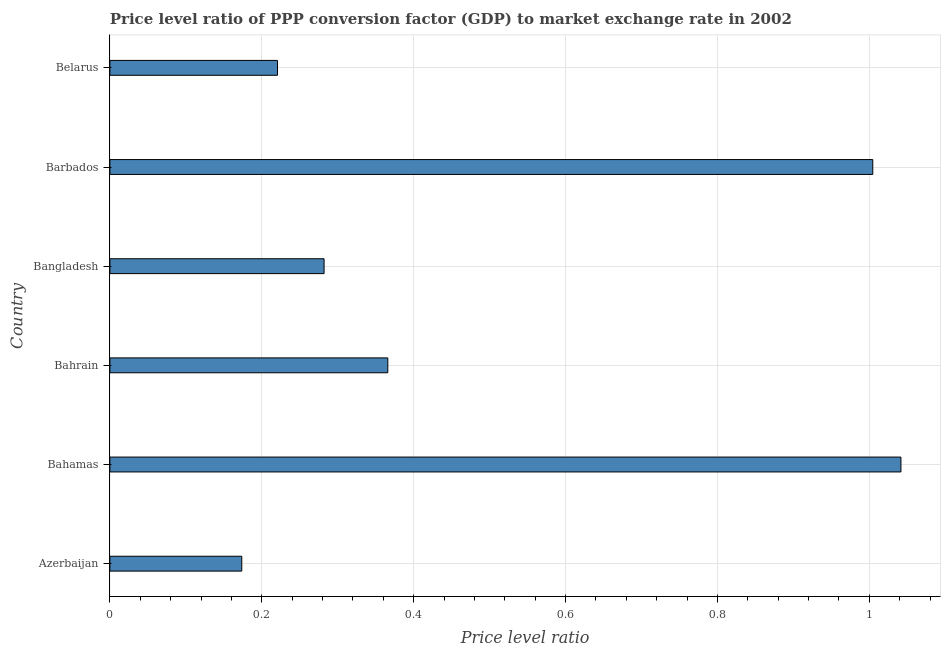What is the title of the graph?
Provide a succinct answer. Price level ratio of PPP conversion factor (GDP) to market exchange rate in 2002. What is the label or title of the X-axis?
Provide a short and direct response. Price level ratio. What is the label or title of the Y-axis?
Your answer should be compact. Country. What is the price level ratio in Bahrain?
Your answer should be compact. 0.37. Across all countries, what is the maximum price level ratio?
Your response must be concise. 1.04. Across all countries, what is the minimum price level ratio?
Ensure brevity in your answer.  0.17. In which country was the price level ratio maximum?
Ensure brevity in your answer.  Bahamas. In which country was the price level ratio minimum?
Your answer should be compact. Azerbaijan. What is the sum of the price level ratio?
Provide a short and direct response. 3.09. What is the difference between the price level ratio in Azerbaijan and Belarus?
Make the answer very short. -0.05. What is the average price level ratio per country?
Give a very brief answer. 0.52. What is the median price level ratio?
Your answer should be compact. 0.32. What is the ratio of the price level ratio in Barbados to that in Belarus?
Your answer should be compact. 4.55. Is the price level ratio in Bahamas less than that in Bahrain?
Your answer should be very brief. No. Is the difference between the price level ratio in Azerbaijan and Belarus greater than the difference between any two countries?
Offer a very short reply. No. What is the difference between the highest and the second highest price level ratio?
Your response must be concise. 0.04. Is the sum of the price level ratio in Bahamas and Bahrain greater than the maximum price level ratio across all countries?
Provide a short and direct response. Yes. What is the difference between the highest and the lowest price level ratio?
Your answer should be very brief. 0.87. In how many countries, is the price level ratio greater than the average price level ratio taken over all countries?
Provide a short and direct response. 2. How many bars are there?
Your answer should be very brief. 6. Are all the bars in the graph horizontal?
Your answer should be very brief. Yes. How many countries are there in the graph?
Ensure brevity in your answer.  6. What is the difference between two consecutive major ticks on the X-axis?
Give a very brief answer. 0.2. What is the Price level ratio of Azerbaijan?
Offer a terse response. 0.17. What is the Price level ratio in Bahamas?
Keep it short and to the point. 1.04. What is the Price level ratio of Bahrain?
Ensure brevity in your answer.  0.37. What is the Price level ratio of Bangladesh?
Offer a terse response. 0.28. What is the Price level ratio in Barbados?
Ensure brevity in your answer.  1. What is the Price level ratio in Belarus?
Give a very brief answer. 0.22. What is the difference between the Price level ratio in Azerbaijan and Bahamas?
Your answer should be compact. -0.87. What is the difference between the Price level ratio in Azerbaijan and Bahrain?
Your response must be concise. -0.19. What is the difference between the Price level ratio in Azerbaijan and Bangladesh?
Provide a short and direct response. -0.11. What is the difference between the Price level ratio in Azerbaijan and Barbados?
Ensure brevity in your answer.  -0.83. What is the difference between the Price level ratio in Azerbaijan and Belarus?
Offer a very short reply. -0.05. What is the difference between the Price level ratio in Bahamas and Bahrain?
Make the answer very short. 0.68. What is the difference between the Price level ratio in Bahamas and Bangladesh?
Ensure brevity in your answer.  0.76. What is the difference between the Price level ratio in Bahamas and Barbados?
Ensure brevity in your answer.  0.04. What is the difference between the Price level ratio in Bahamas and Belarus?
Your response must be concise. 0.82. What is the difference between the Price level ratio in Bahrain and Bangladesh?
Ensure brevity in your answer.  0.08. What is the difference between the Price level ratio in Bahrain and Barbados?
Make the answer very short. -0.64. What is the difference between the Price level ratio in Bahrain and Belarus?
Make the answer very short. 0.15. What is the difference between the Price level ratio in Bangladesh and Barbados?
Your response must be concise. -0.72. What is the difference between the Price level ratio in Bangladesh and Belarus?
Your answer should be very brief. 0.06. What is the difference between the Price level ratio in Barbados and Belarus?
Provide a short and direct response. 0.78. What is the ratio of the Price level ratio in Azerbaijan to that in Bahamas?
Provide a short and direct response. 0.17. What is the ratio of the Price level ratio in Azerbaijan to that in Bahrain?
Give a very brief answer. 0.47. What is the ratio of the Price level ratio in Azerbaijan to that in Bangladesh?
Make the answer very short. 0.62. What is the ratio of the Price level ratio in Azerbaijan to that in Barbados?
Your answer should be compact. 0.17. What is the ratio of the Price level ratio in Azerbaijan to that in Belarus?
Provide a short and direct response. 0.79. What is the ratio of the Price level ratio in Bahamas to that in Bahrain?
Provide a short and direct response. 2.85. What is the ratio of the Price level ratio in Bahamas to that in Bangladesh?
Offer a terse response. 3.69. What is the ratio of the Price level ratio in Bahamas to that in Belarus?
Provide a succinct answer. 4.72. What is the ratio of the Price level ratio in Bahrain to that in Bangladesh?
Offer a very short reply. 1.3. What is the ratio of the Price level ratio in Bahrain to that in Barbados?
Ensure brevity in your answer.  0.36. What is the ratio of the Price level ratio in Bahrain to that in Belarus?
Ensure brevity in your answer.  1.66. What is the ratio of the Price level ratio in Bangladesh to that in Barbados?
Provide a short and direct response. 0.28. What is the ratio of the Price level ratio in Bangladesh to that in Belarus?
Offer a very short reply. 1.28. What is the ratio of the Price level ratio in Barbados to that in Belarus?
Provide a short and direct response. 4.55. 